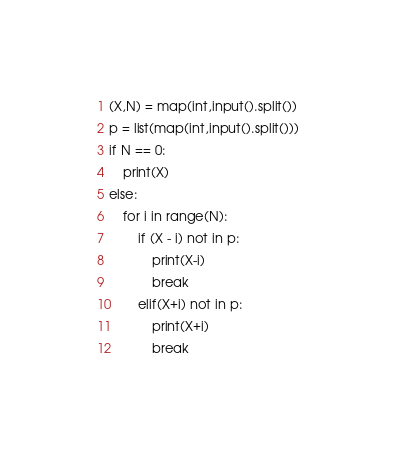Convert code to text. <code><loc_0><loc_0><loc_500><loc_500><_Python_>(X,N) = map(int,input().split())
p = list(map(int,input().split()))
if N == 0:
    print(X)
else:
    for i in range(N):
        if (X - i) not in p:
            print(X-i)
            break
        elif(X+i) not in p:
            print(X+i)
            break
</code> 